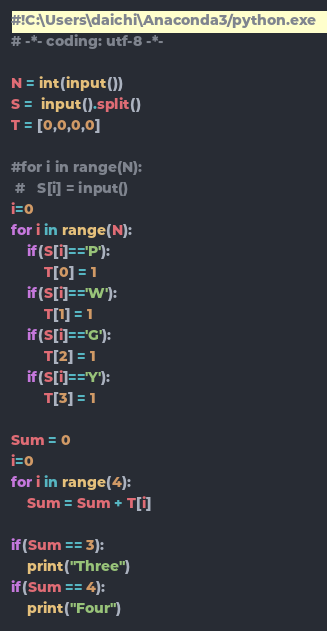<code> <loc_0><loc_0><loc_500><loc_500><_Python_>#!C:\Users\daichi\Anaconda3/python.exe
# -*- coding: utf-8 -*-

N = int(input())
S =  input().split()
T = [0,0,0,0]

#for i in range(N):
 #   S[i] = input()
i=0
for i in range(N):
    if(S[i]=='P'):
        T[0] = 1
    if(S[i]=='W'):
        T[1] = 1
    if(S[i]=='G'):
        T[2] = 1
    if(S[i]=='Y'):
        T[3] = 1

Sum = 0
i=0
for i in range(4):
    Sum = Sum + T[i]
    
if(Sum == 3):
    print("Three")
if(Sum == 4):
    print("Four")</code> 